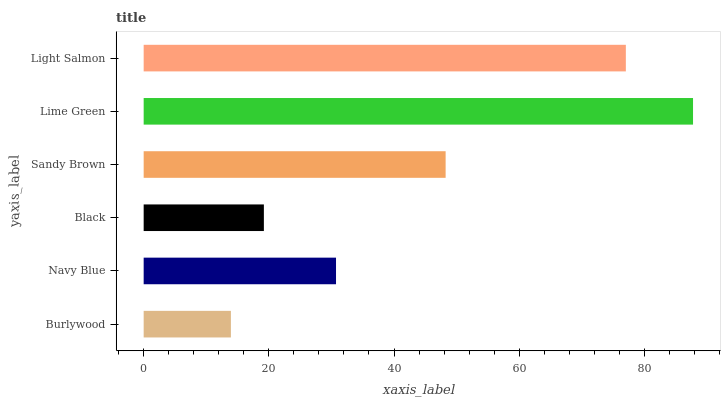Is Burlywood the minimum?
Answer yes or no. Yes. Is Lime Green the maximum?
Answer yes or no. Yes. Is Navy Blue the minimum?
Answer yes or no. No. Is Navy Blue the maximum?
Answer yes or no. No. Is Navy Blue greater than Burlywood?
Answer yes or no. Yes. Is Burlywood less than Navy Blue?
Answer yes or no. Yes. Is Burlywood greater than Navy Blue?
Answer yes or no. No. Is Navy Blue less than Burlywood?
Answer yes or no. No. Is Sandy Brown the high median?
Answer yes or no. Yes. Is Navy Blue the low median?
Answer yes or no. Yes. Is Black the high median?
Answer yes or no. No. Is Sandy Brown the low median?
Answer yes or no. No. 